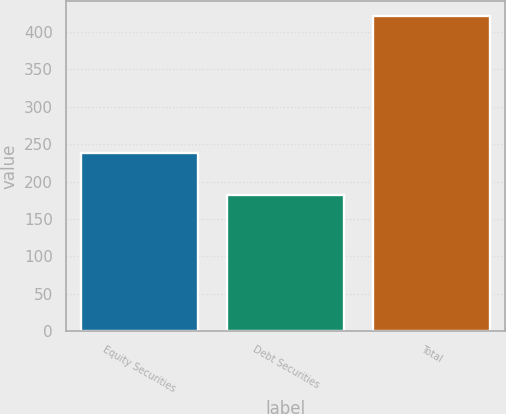<chart> <loc_0><loc_0><loc_500><loc_500><bar_chart><fcel>Equity Securities<fcel>Debt Securities<fcel>Total<nl><fcel>238.7<fcel>182.2<fcel>420.9<nl></chart> 